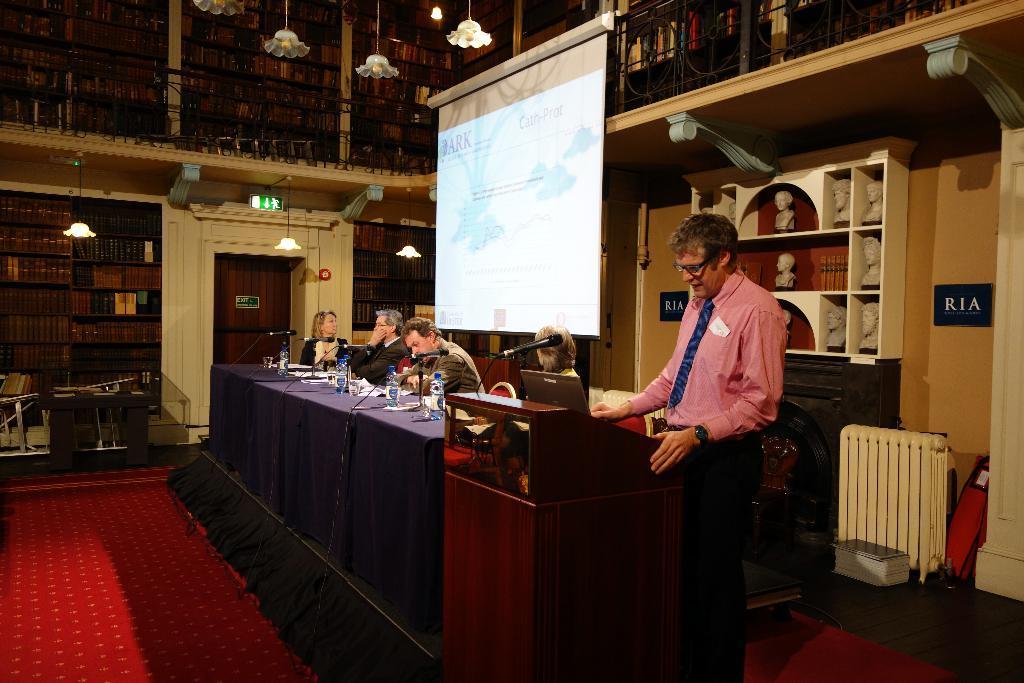Please provide a concise description of this image. In this image there is a person standing on the dais, is speaking in front of a mic by looking into a laptop on the table, beside him there are a few people seated on chairs, in front of them on the table there are mice, bottles of water and papers, behind them there is a screen, behind the screen there are a few statues on the shelf and there are name boards on the wall, there is a fireplace, a room heater and some other objects, beside the table there are some books on the bookshelf and there is a closed wooden door, on top of the door there is an exit symbol and a lamp, in front of the shelf there is a table and chairs and some books on the table, at the top of the image on the first floor there is a metal fence, on the other side of the fence there are books in a book shelf and there are lamps hanging from the ceiling. 